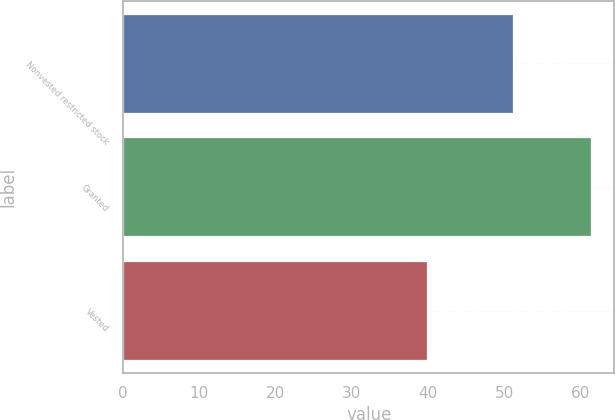<chart> <loc_0><loc_0><loc_500><loc_500><bar_chart><fcel>Nonvested restricted stock<fcel>Granted<fcel>Vested<nl><fcel>51.11<fcel>61.38<fcel>39.9<nl></chart> 